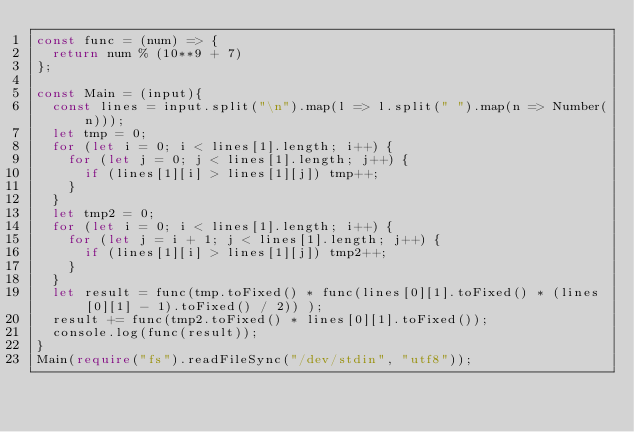<code> <loc_0><loc_0><loc_500><loc_500><_TypeScript_>const func = (num) => {
  return num % (10**9 + 7)
};

const Main = (input){
  const lines = input.split("\n").map(l => l.split(" ").map(n => Number(n)));
  let tmp = 0;
  for (let i = 0; i < lines[1].length; i++) {
    for (let j = 0; j < lines[1].length; j++) {
      if (lines[1][i] > lines[1][j]) tmp++;
    }
  }
  let tmp2 = 0;
  for (let i = 0; i < lines[1].length; i++) {
    for (let j = i + 1; j < lines[1].length; j++) {
      if (lines[1][i] > lines[1][j]) tmp2++;
    }
  }
  let result = func(tmp.toFixed() * func(lines[0][1].toFixed() * (lines[0][1] - 1).toFixed() / 2)) );
  result += func(tmp2.toFixed() * lines[0][1].toFixed());
  console.log(func(result));
}
Main(require("fs").readFileSync("/dev/stdin", "utf8"));
</code> 